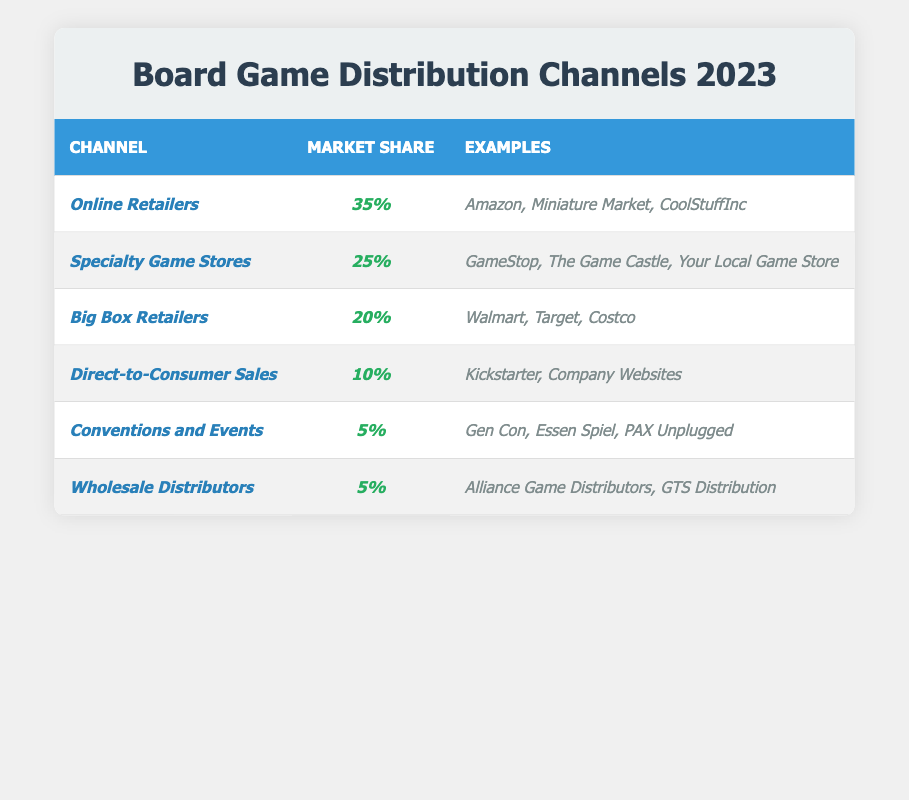Which distribution channel has the highest market share? The channel with the highest market share can be found by looking at the first row of the table. It shows that "Online Retailers" have a market share of 35%, which is greater than any other channel listed.
Answer: Online Retailers What is the market share percentage of Specialty Game Stores? The market share percentage for Specialty Game Stores is provided in the second row of the table. It states they have a market share of 25%.
Answer: 25% How much market share do Big Box Retailers and Direct-to-Consumer Sales hold combined? To find the combined market share, add the percentages for Big Box Retailers (20%) and Direct-to-Consumer Sales (10%). Summing them gives 20 + 10 = 30%.
Answer: 30% Is the market share of Conventions and Events greater than that of Wholesale Distributors? In the fifth row, the market share for Conventions and Events is 5%, and in the sixth row, the market share for Wholesale Distributors is also 5%. Since these values are equal, the statement is false.
Answer: No What percentage of market share is attributed to online and direct-to-consumer channels combined, compared to specialty game stores? First, find the market share for Online Retailers (35%) and Direct-to-Consumer Sales (10%) and add them, getting 35 + 10 = 45%. Specialty Game Stores have 25%, which is less than 45%. Thus, online and direct-to-consumer channels combined are greater than specialty game stores.
Answer: Yes What is the difference in market share between Big Box Retailers and Conventions and Events? The market share for Big Box Retailers is 20%, while for Conventions and Events is 5%. To find the difference, subtract the lower percentage from the higher percentage: 20 - 5 = 15%.
Answer: 15% If you were to rank the channels by their market share, which channel would be in the second place? The second highest market share can be identified by examining the sorted percentages from highest to lowest: Online Retailers (35%), Specialty Game Stores (25%), which places Specialty Game Stores in second place.
Answer: Specialty Game Stores What percentage of the market is not covered by the top three distribution channels? The top three channels (Online Retailers, Specialty Game Stores, Big Box Retailers) have market shares of 35%, 25%, and 20% respectively. Adding these gives 35 + 25 + 20 = 80%. Thus, the remaining market share is 100% - 80% = 20%.
Answer: 20% How do the market shares of Direct-to-Consumer Sales and Wholesale Distributors compare? Direct-to-Consumer Sales have a market share of 10%, and Wholesale Distributors have 5%. Since 10% is greater than 5%, Direct-to-Consumer Sales have a higher market share.
Answer: Direct-to-Consumer Sales are higher What is the total market share represented by the last two channels: Conventions and Events and Wholesale Distributors? To find the total market share for the last two channels, add their market shares: Conventions and Events (5%) + Wholesale Distributors (5%) equals 10%.
Answer: 10% 